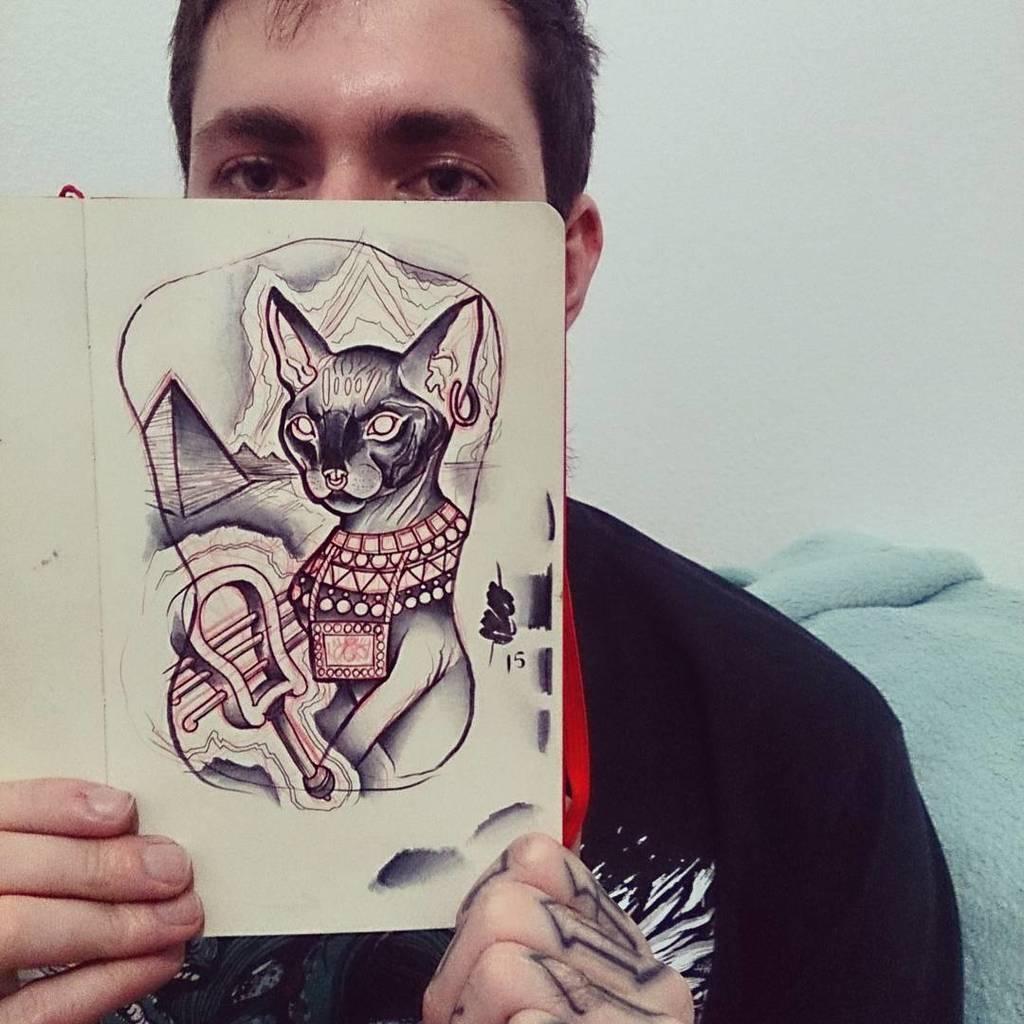Describe this image in one or two sentences. Background portion of the picture is in white color and it seems like the wall. In this picture we can see a man holding a book. We can see an art. On the right side of the picture we can see the blanket. 